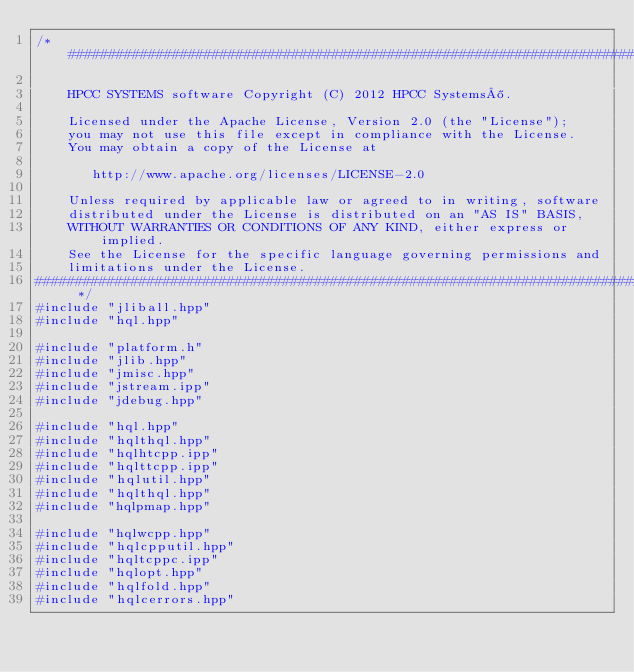Convert code to text. <code><loc_0><loc_0><loc_500><loc_500><_C++_>/*##############################################################################

    HPCC SYSTEMS software Copyright (C) 2012 HPCC Systems®.

    Licensed under the Apache License, Version 2.0 (the "License");
    you may not use this file except in compliance with the License.
    You may obtain a copy of the License at

       http://www.apache.org/licenses/LICENSE-2.0

    Unless required by applicable law or agreed to in writing, software
    distributed under the License is distributed on an "AS IS" BASIS,
    WITHOUT WARRANTIES OR CONDITIONS OF ANY KIND, either express or implied.
    See the License for the specific language governing permissions and
    limitations under the License.
############################################################################## */
#include "jliball.hpp"
#include "hql.hpp"

#include "platform.h"
#include "jlib.hpp"
#include "jmisc.hpp"
#include "jstream.ipp"
#include "jdebug.hpp"

#include "hql.hpp"
#include "hqlthql.hpp"
#include "hqlhtcpp.ipp"
#include "hqlttcpp.ipp"
#include "hqlutil.hpp"
#include "hqlthql.hpp"
#include "hqlpmap.hpp"

#include "hqlwcpp.hpp"
#include "hqlcpputil.hpp"
#include "hqltcppc.ipp"
#include "hqlopt.hpp"
#include "hqlfold.hpp"
#include "hqlcerrors.hpp"</code> 